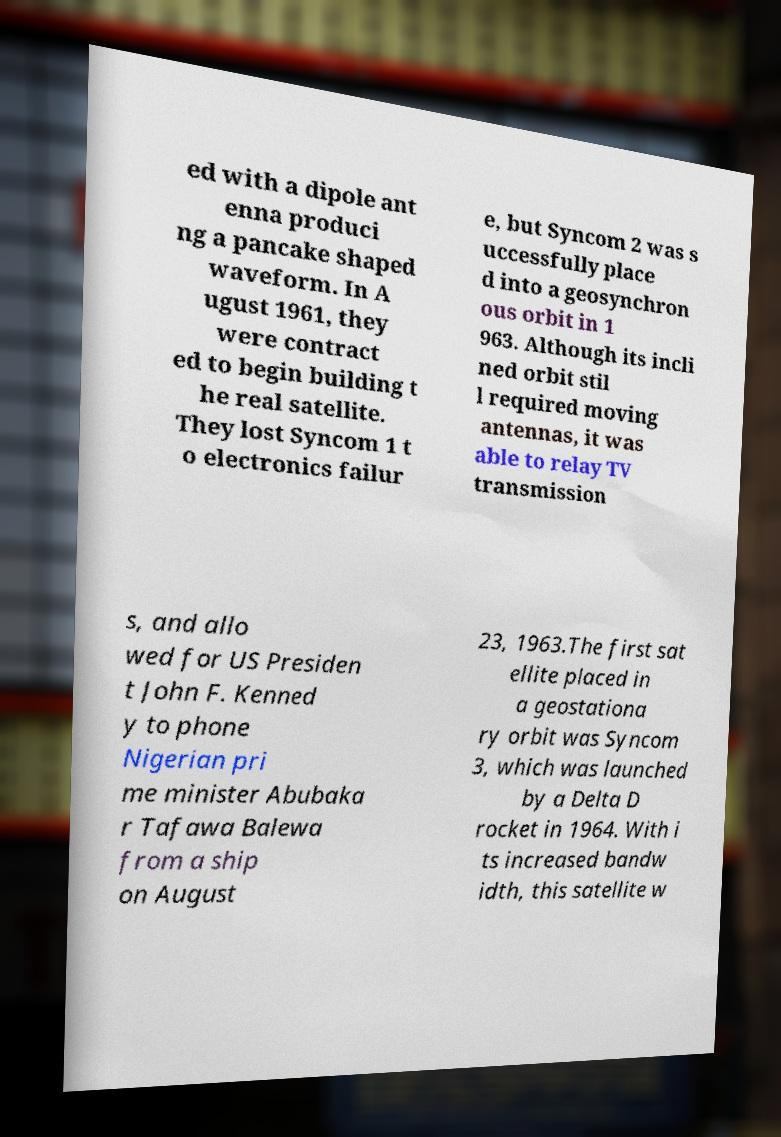What messages or text are displayed in this image? I need them in a readable, typed format. ed with a dipole ant enna produci ng a pancake shaped waveform. In A ugust 1961, they were contract ed to begin building t he real satellite. They lost Syncom 1 t o electronics failur e, but Syncom 2 was s uccessfully place d into a geosynchron ous orbit in 1 963. Although its incli ned orbit stil l required moving antennas, it was able to relay TV transmission s, and allo wed for US Presiden t John F. Kenned y to phone Nigerian pri me minister Abubaka r Tafawa Balewa from a ship on August 23, 1963.The first sat ellite placed in a geostationa ry orbit was Syncom 3, which was launched by a Delta D rocket in 1964. With i ts increased bandw idth, this satellite w 